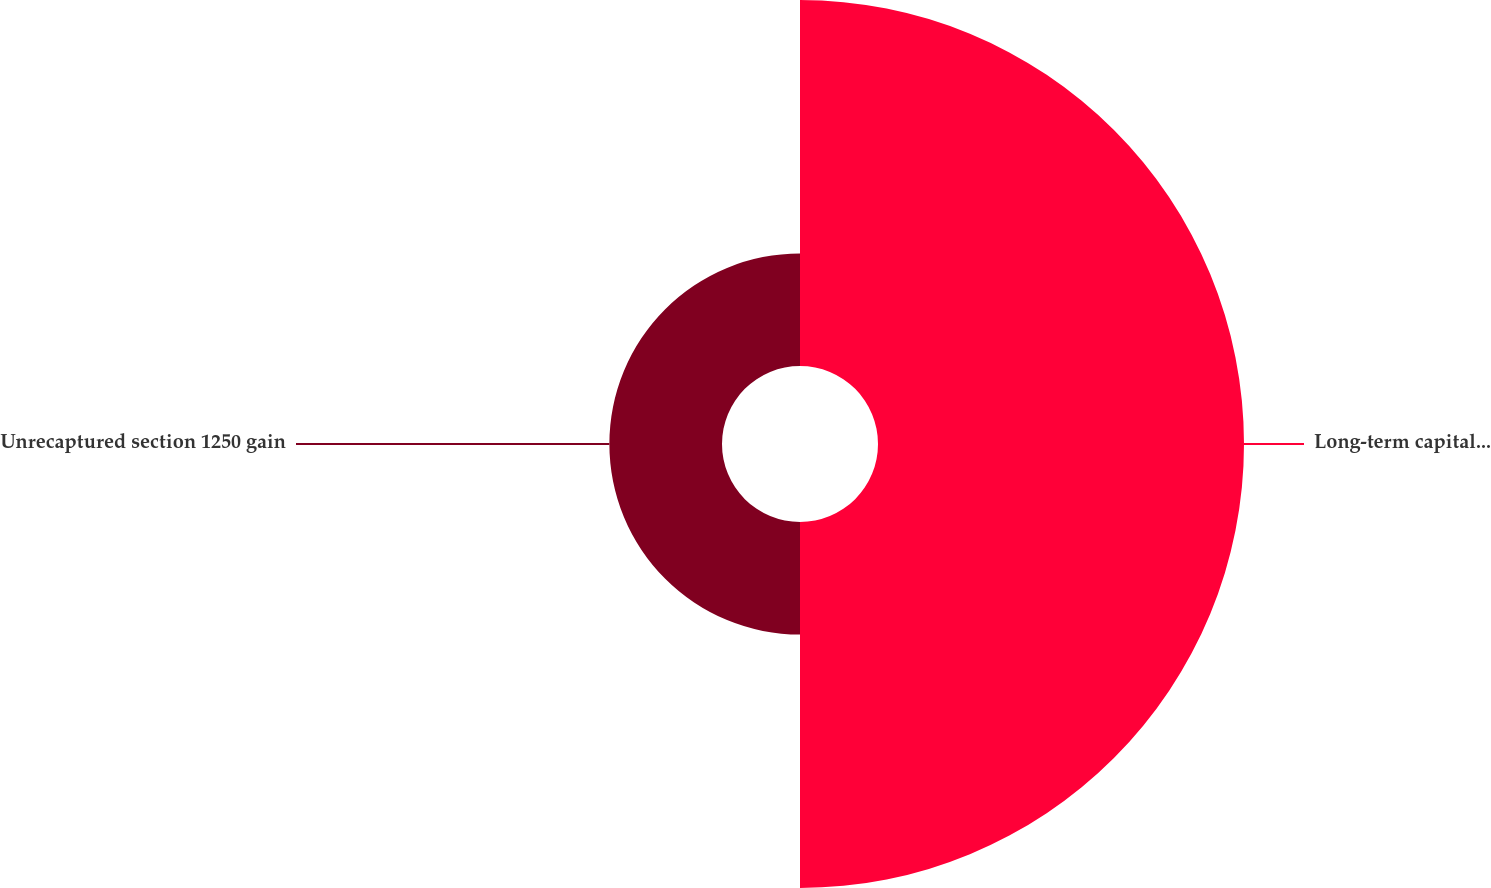Convert chart to OTSL. <chart><loc_0><loc_0><loc_500><loc_500><pie_chart><fcel>Long-term capital gain<fcel>Unrecaptured section 1250 gain<nl><fcel>76.47%<fcel>23.53%<nl></chart> 